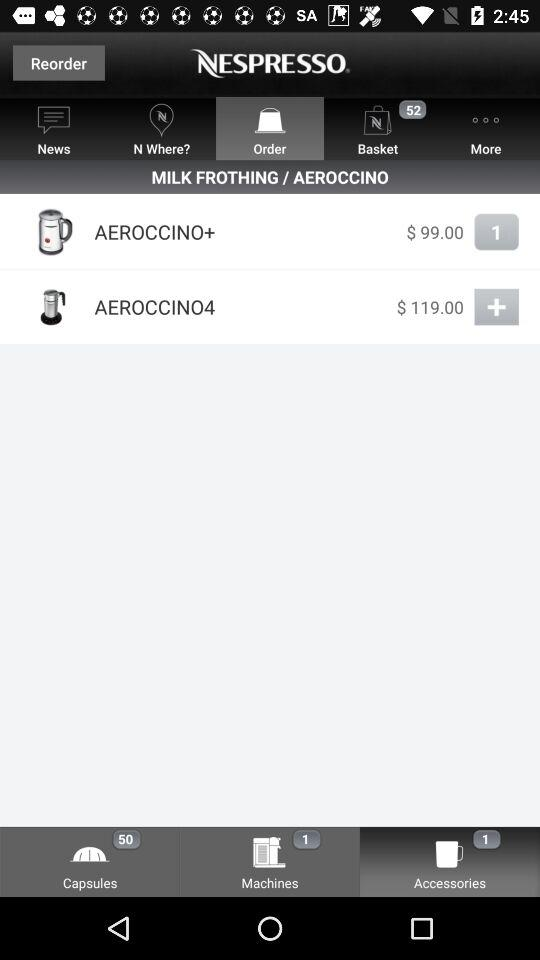What is the count of items in the basket? The count of items in the basket is 52. 